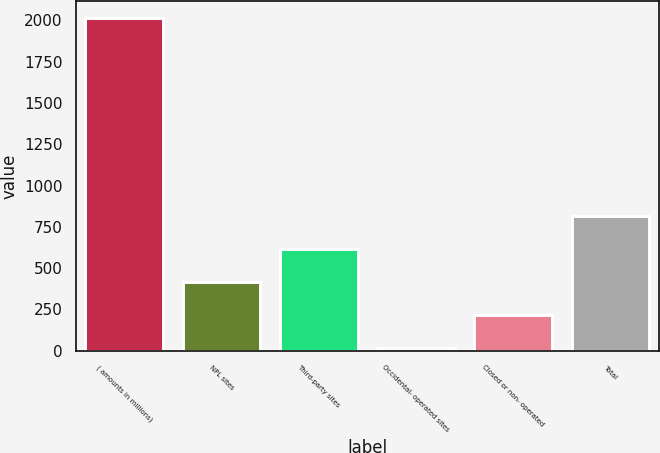<chart> <loc_0><loc_0><loc_500><loc_500><bar_chart><fcel>( amounts in millions)<fcel>NPL sites<fcel>Third-party sites<fcel>Occidental- operated sites<fcel>Closed or non- operated<fcel>Total<nl><fcel>2015<fcel>417.4<fcel>617.1<fcel>18<fcel>217.7<fcel>816.8<nl></chart> 